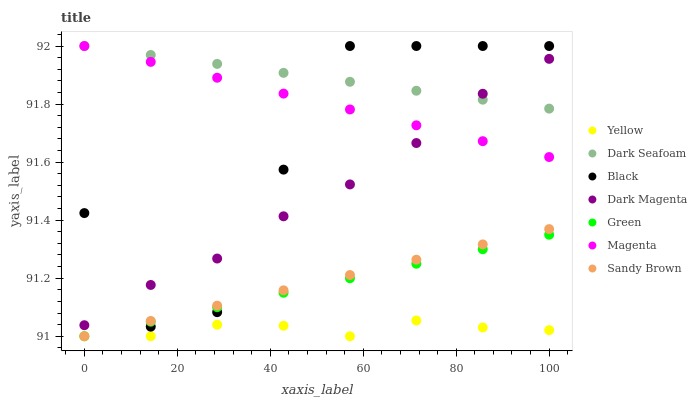Does Yellow have the minimum area under the curve?
Answer yes or no. Yes. Does Dark Seafoam have the maximum area under the curve?
Answer yes or no. Yes. Does Dark Seafoam have the minimum area under the curve?
Answer yes or no. No. Does Yellow have the maximum area under the curve?
Answer yes or no. No. Is Green the smoothest?
Answer yes or no. Yes. Is Black the roughest?
Answer yes or no. Yes. Is Yellow the smoothest?
Answer yes or no. No. Is Yellow the roughest?
Answer yes or no. No. Does Yellow have the lowest value?
Answer yes or no. Yes. Does Dark Seafoam have the lowest value?
Answer yes or no. No. Does Magenta have the highest value?
Answer yes or no. Yes. Does Yellow have the highest value?
Answer yes or no. No. Is Sandy Brown less than Dark Seafoam?
Answer yes or no. Yes. Is Dark Seafoam greater than Green?
Answer yes or no. Yes. Does Dark Seafoam intersect Magenta?
Answer yes or no. Yes. Is Dark Seafoam less than Magenta?
Answer yes or no. No. Is Dark Seafoam greater than Magenta?
Answer yes or no. No. Does Sandy Brown intersect Dark Seafoam?
Answer yes or no. No. 